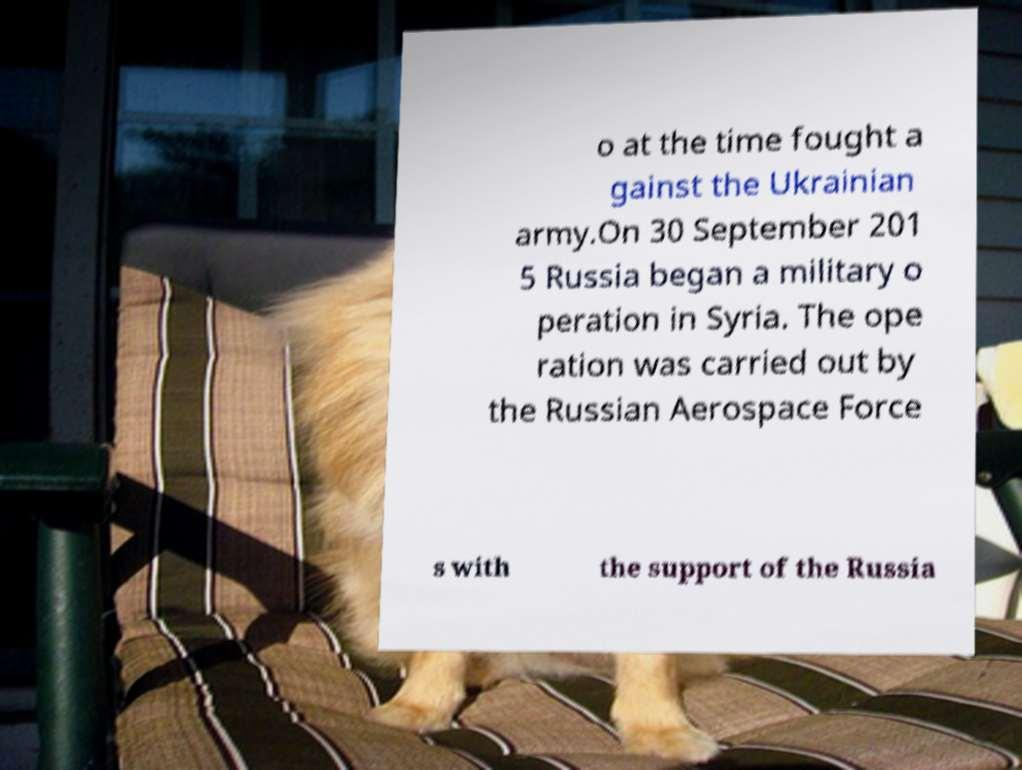There's text embedded in this image that I need extracted. Can you transcribe it verbatim? o at the time fought a gainst the Ukrainian army.On 30 September 201 5 Russia began a military o peration in Syria. The ope ration was carried out by the Russian Aerospace Force s with the support of the Russia 